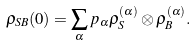<formula> <loc_0><loc_0><loc_500><loc_500>\rho _ { S B } ( 0 ) = \sum _ { \alpha } p _ { \alpha } \rho _ { S } ^ { ( \alpha ) } \otimes \rho _ { B } ^ { ( \alpha ) } .</formula> 